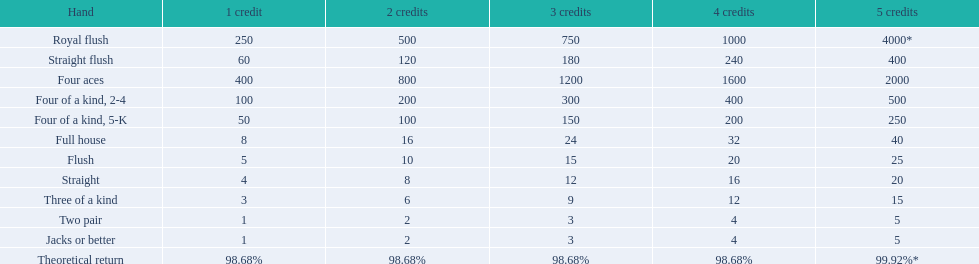What do the various hands consist of? Royal flush, Straight flush, Four aces, Four of a kind, 2-4, Four of a kind, 5-K, Full house, Flush, Straight, Three of a kind, Two pair, Jacks or better, Theoretical return. Between straights and flushes, which one has a higher ranking? Flush. 